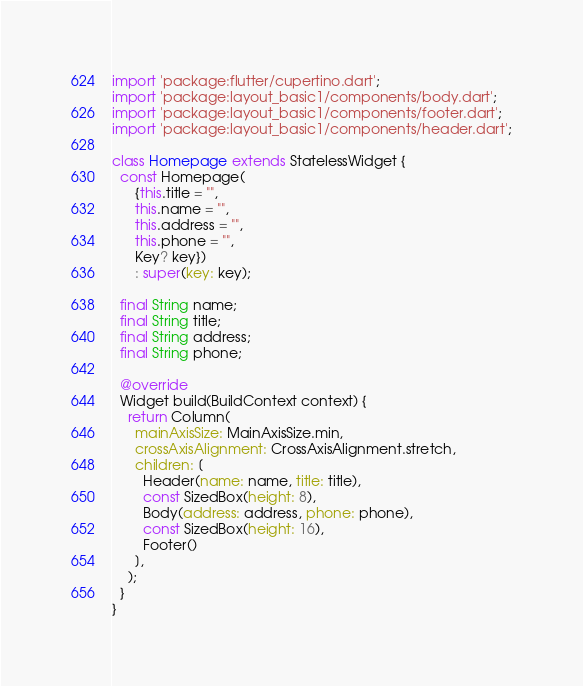<code> <loc_0><loc_0><loc_500><loc_500><_Dart_>import 'package:flutter/cupertino.dart';
import 'package:layout_basic1/components/body.dart';
import 'package:layout_basic1/components/footer.dart';
import 'package:layout_basic1/components/header.dart';

class Homepage extends StatelessWidget {
  const Homepage(
      {this.title = "",
      this.name = "",
      this.address = "",
      this.phone = "",
      Key? key})
      : super(key: key);

  final String name;
  final String title;
  final String address;
  final String phone;

  @override
  Widget build(BuildContext context) {
    return Column(
      mainAxisSize: MainAxisSize.min,
      crossAxisAlignment: CrossAxisAlignment.stretch,
      children: [
        Header(name: name, title: title),
        const SizedBox(height: 8),
        Body(address: address, phone: phone),
        const SizedBox(height: 16),
        Footer()
      ],
    );
  }
}
</code> 